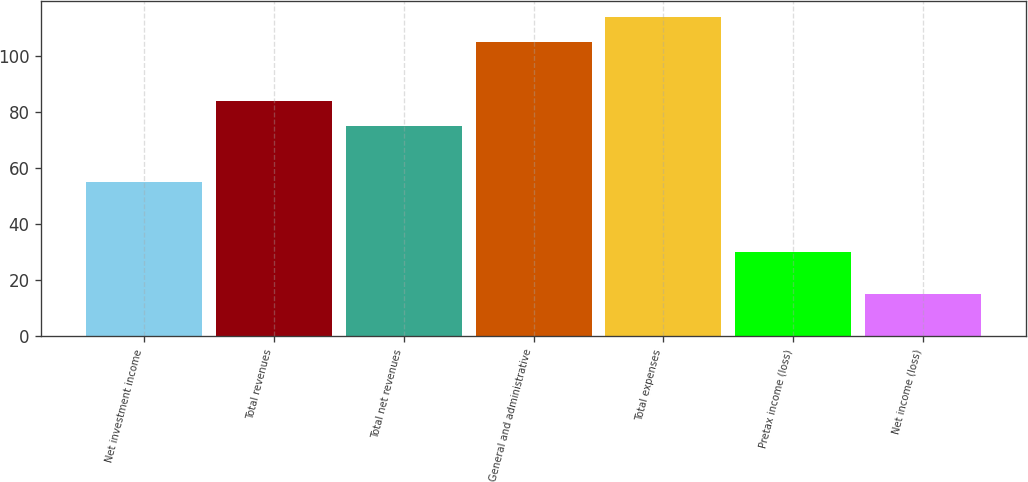Convert chart. <chart><loc_0><loc_0><loc_500><loc_500><bar_chart><fcel>Net investment income<fcel>Total revenues<fcel>Total net revenues<fcel>General and administrative<fcel>Total expenses<fcel>Pretax income (loss)<fcel>Net income (loss)<nl><fcel>55<fcel>84<fcel>75<fcel>105<fcel>114<fcel>30<fcel>15<nl></chart> 